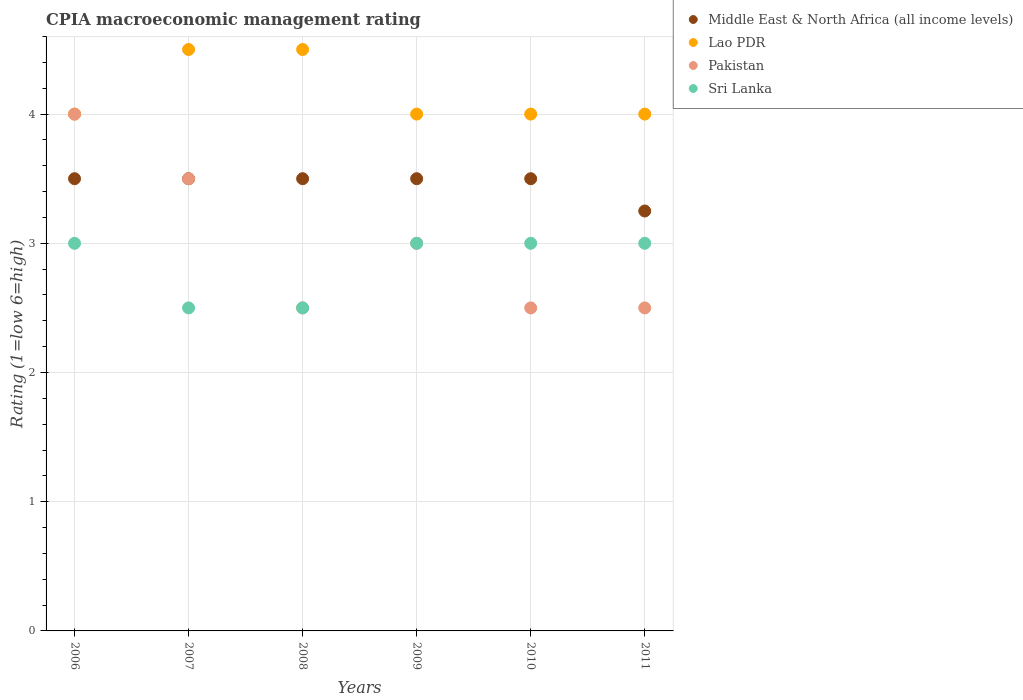Is the number of dotlines equal to the number of legend labels?
Make the answer very short. Yes. In which year was the CPIA rating in Sri Lanka maximum?
Make the answer very short. 2006. In which year was the CPIA rating in Lao PDR minimum?
Provide a succinct answer. 2006. What is the total CPIA rating in Middle East & North Africa (all income levels) in the graph?
Your answer should be compact. 20.75. What is the difference between the CPIA rating in Pakistan in 2006 and the CPIA rating in Sri Lanka in 2011?
Your answer should be compact. 1. What is the ratio of the CPIA rating in Pakistan in 2009 to that in 2011?
Your response must be concise. 1.2. Is the CPIA rating in Sri Lanka in 2008 less than that in 2010?
Your answer should be compact. Yes. Is the difference between the CPIA rating in Middle East & North Africa (all income levels) in 2007 and 2010 greater than the difference between the CPIA rating in Sri Lanka in 2007 and 2010?
Your answer should be compact. Yes. What is the difference between the highest and the second highest CPIA rating in Sri Lanka?
Offer a terse response. 0. What is the difference between the highest and the lowest CPIA rating in Middle East & North Africa (all income levels)?
Give a very brief answer. 0.25. Is the sum of the CPIA rating in Sri Lanka in 2006 and 2008 greater than the maximum CPIA rating in Middle East & North Africa (all income levels) across all years?
Provide a short and direct response. Yes. Is it the case that in every year, the sum of the CPIA rating in Lao PDR and CPIA rating in Pakistan  is greater than the sum of CPIA rating in Middle East & North Africa (all income levels) and CPIA rating in Sri Lanka?
Give a very brief answer. Yes. Is it the case that in every year, the sum of the CPIA rating in Pakistan and CPIA rating in Middle East & North Africa (all income levels)  is greater than the CPIA rating in Sri Lanka?
Your response must be concise. Yes. Does the CPIA rating in Sri Lanka monotonically increase over the years?
Your response must be concise. No. How many dotlines are there?
Your answer should be compact. 4. How many years are there in the graph?
Offer a very short reply. 6. What is the difference between two consecutive major ticks on the Y-axis?
Make the answer very short. 1. Where does the legend appear in the graph?
Ensure brevity in your answer.  Top right. How are the legend labels stacked?
Your answer should be compact. Vertical. What is the title of the graph?
Your response must be concise. CPIA macroeconomic management rating. What is the Rating (1=low 6=high) of Lao PDR in 2006?
Keep it short and to the point. 4. What is the Rating (1=low 6=high) in Pakistan in 2006?
Your answer should be very brief. 4. What is the Rating (1=low 6=high) of Middle East & North Africa (all income levels) in 2007?
Provide a succinct answer. 3.5. What is the Rating (1=low 6=high) of Pakistan in 2007?
Your answer should be compact. 3.5. What is the Rating (1=low 6=high) of Sri Lanka in 2007?
Keep it short and to the point. 2.5. What is the Rating (1=low 6=high) of Pakistan in 2008?
Offer a terse response. 2.5. What is the Rating (1=low 6=high) of Middle East & North Africa (all income levels) in 2009?
Offer a terse response. 3.5. What is the Rating (1=low 6=high) in Sri Lanka in 2009?
Offer a terse response. 3. What is the Rating (1=low 6=high) of Middle East & North Africa (all income levels) in 2010?
Provide a succinct answer. 3.5. What is the Rating (1=low 6=high) in Pakistan in 2010?
Give a very brief answer. 2.5. What is the Rating (1=low 6=high) in Sri Lanka in 2010?
Keep it short and to the point. 3. What is the Rating (1=low 6=high) of Sri Lanka in 2011?
Your answer should be very brief. 3. Across all years, what is the maximum Rating (1=low 6=high) in Middle East & North Africa (all income levels)?
Provide a succinct answer. 3.5. Across all years, what is the maximum Rating (1=low 6=high) of Lao PDR?
Give a very brief answer. 4.5. Across all years, what is the minimum Rating (1=low 6=high) of Pakistan?
Your answer should be compact. 2.5. What is the total Rating (1=low 6=high) in Middle East & North Africa (all income levels) in the graph?
Offer a very short reply. 20.75. What is the total Rating (1=low 6=high) of Lao PDR in the graph?
Your answer should be compact. 25. What is the total Rating (1=low 6=high) in Pakistan in the graph?
Make the answer very short. 18. What is the total Rating (1=low 6=high) of Sri Lanka in the graph?
Keep it short and to the point. 17. What is the difference between the Rating (1=low 6=high) in Middle East & North Africa (all income levels) in 2006 and that in 2007?
Offer a very short reply. 0. What is the difference between the Rating (1=low 6=high) in Sri Lanka in 2006 and that in 2007?
Offer a very short reply. 0.5. What is the difference between the Rating (1=low 6=high) in Lao PDR in 2006 and that in 2008?
Provide a short and direct response. -0.5. What is the difference between the Rating (1=low 6=high) of Pakistan in 2006 and that in 2008?
Give a very brief answer. 1.5. What is the difference between the Rating (1=low 6=high) in Sri Lanka in 2006 and that in 2008?
Keep it short and to the point. 0.5. What is the difference between the Rating (1=low 6=high) in Middle East & North Africa (all income levels) in 2006 and that in 2009?
Offer a terse response. 0. What is the difference between the Rating (1=low 6=high) in Lao PDR in 2006 and that in 2009?
Ensure brevity in your answer.  0. What is the difference between the Rating (1=low 6=high) in Pakistan in 2006 and that in 2009?
Your answer should be compact. 1. What is the difference between the Rating (1=low 6=high) of Sri Lanka in 2006 and that in 2009?
Provide a succinct answer. 0. What is the difference between the Rating (1=low 6=high) in Middle East & North Africa (all income levels) in 2006 and that in 2010?
Offer a terse response. 0. What is the difference between the Rating (1=low 6=high) of Lao PDR in 2006 and that in 2010?
Ensure brevity in your answer.  0. What is the difference between the Rating (1=low 6=high) of Pakistan in 2006 and that in 2010?
Your response must be concise. 1.5. What is the difference between the Rating (1=low 6=high) in Lao PDR in 2006 and that in 2011?
Keep it short and to the point. 0. What is the difference between the Rating (1=low 6=high) of Pakistan in 2006 and that in 2011?
Provide a short and direct response. 1.5. What is the difference between the Rating (1=low 6=high) in Sri Lanka in 2007 and that in 2008?
Keep it short and to the point. 0. What is the difference between the Rating (1=low 6=high) in Middle East & North Africa (all income levels) in 2007 and that in 2009?
Ensure brevity in your answer.  0. What is the difference between the Rating (1=low 6=high) in Sri Lanka in 2007 and that in 2009?
Offer a very short reply. -0.5. What is the difference between the Rating (1=low 6=high) in Middle East & North Africa (all income levels) in 2007 and that in 2010?
Offer a very short reply. 0. What is the difference between the Rating (1=low 6=high) of Lao PDR in 2007 and that in 2010?
Give a very brief answer. 0.5. What is the difference between the Rating (1=low 6=high) in Pakistan in 2007 and that in 2010?
Provide a succinct answer. 1. What is the difference between the Rating (1=low 6=high) in Sri Lanka in 2007 and that in 2010?
Your response must be concise. -0.5. What is the difference between the Rating (1=low 6=high) in Lao PDR in 2007 and that in 2011?
Your answer should be very brief. 0.5. What is the difference between the Rating (1=low 6=high) of Pakistan in 2007 and that in 2011?
Your answer should be compact. 1. What is the difference between the Rating (1=low 6=high) in Middle East & North Africa (all income levels) in 2008 and that in 2009?
Keep it short and to the point. 0. What is the difference between the Rating (1=low 6=high) of Lao PDR in 2008 and that in 2009?
Your answer should be very brief. 0.5. What is the difference between the Rating (1=low 6=high) in Pakistan in 2008 and that in 2009?
Ensure brevity in your answer.  -0.5. What is the difference between the Rating (1=low 6=high) in Sri Lanka in 2008 and that in 2009?
Give a very brief answer. -0.5. What is the difference between the Rating (1=low 6=high) of Pakistan in 2008 and that in 2010?
Offer a terse response. 0. What is the difference between the Rating (1=low 6=high) of Sri Lanka in 2008 and that in 2010?
Provide a succinct answer. -0.5. What is the difference between the Rating (1=low 6=high) in Middle East & North Africa (all income levels) in 2008 and that in 2011?
Make the answer very short. 0.25. What is the difference between the Rating (1=low 6=high) in Pakistan in 2008 and that in 2011?
Offer a very short reply. 0. What is the difference between the Rating (1=low 6=high) of Sri Lanka in 2008 and that in 2011?
Offer a very short reply. -0.5. What is the difference between the Rating (1=low 6=high) in Middle East & North Africa (all income levels) in 2009 and that in 2010?
Your answer should be very brief. 0. What is the difference between the Rating (1=low 6=high) of Lao PDR in 2009 and that in 2010?
Your answer should be very brief. 0. What is the difference between the Rating (1=low 6=high) of Pakistan in 2009 and that in 2010?
Your answer should be compact. 0.5. What is the difference between the Rating (1=low 6=high) in Sri Lanka in 2009 and that in 2010?
Keep it short and to the point. 0. What is the difference between the Rating (1=low 6=high) in Middle East & North Africa (all income levels) in 2009 and that in 2011?
Your response must be concise. 0.25. What is the difference between the Rating (1=low 6=high) in Pakistan in 2009 and that in 2011?
Give a very brief answer. 0.5. What is the difference between the Rating (1=low 6=high) in Sri Lanka in 2009 and that in 2011?
Offer a terse response. 0. What is the difference between the Rating (1=low 6=high) in Lao PDR in 2010 and that in 2011?
Ensure brevity in your answer.  0. What is the difference between the Rating (1=low 6=high) of Middle East & North Africa (all income levels) in 2006 and the Rating (1=low 6=high) of Pakistan in 2007?
Make the answer very short. 0. What is the difference between the Rating (1=low 6=high) in Middle East & North Africa (all income levels) in 2006 and the Rating (1=low 6=high) in Sri Lanka in 2007?
Your answer should be very brief. 1. What is the difference between the Rating (1=low 6=high) of Lao PDR in 2006 and the Rating (1=low 6=high) of Sri Lanka in 2007?
Make the answer very short. 1.5. What is the difference between the Rating (1=low 6=high) of Pakistan in 2006 and the Rating (1=low 6=high) of Sri Lanka in 2007?
Offer a very short reply. 1.5. What is the difference between the Rating (1=low 6=high) of Middle East & North Africa (all income levels) in 2006 and the Rating (1=low 6=high) of Pakistan in 2008?
Your answer should be compact. 1. What is the difference between the Rating (1=low 6=high) in Middle East & North Africa (all income levels) in 2006 and the Rating (1=low 6=high) in Sri Lanka in 2008?
Ensure brevity in your answer.  1. What is the difference between the Rating (1=low 6=high) of Lao PDR in 2006 and the Rating (1=low 6=high) of Pakistan in 2008?
Keep it short and to the point. 1.5. What is the difference between the Rating (1=low 6=high) of Middle East & North Africa (all income levels) in 2006 and the Rating (1=low 6=high) of Sri Lanka in 2009?
Provide a succinct answer. 0.5. What is the difference between the Rating (1=low 6=high) in Lao PDR in 2006 and the Rating (1=low 6=high) in Pakistan in 2009?
Keep it short and to the point. 1. What is the difference between the Rating (1=low 6=high) of Pakistan in 2006 and the Rating (1=low 6=high) of Sri Lanka in 2009?
Your response must be concise. 1. What is the difference between the Rating (1=low 6=high) in Middle East & North Africa (all income levels) in 2006 and the Rating (1=low 6=high) in Sri Lanka in 2010?
Your answer should be compact. 0.5. What is the difference between the Rating (1=low 6=high) of Pakistan in 2006 and the Rating (1=low 6=high) of Sri Lanka in 2010?
Your answer should be compact. 1. What is the difference between the Rating (1=low 6=high) in Middle East & North Africa (all income levels) in 2006 and the Rating (1=low 6=high) in Lao PDR in 2011?
Ensure brevity in your answer.  -0.5. What is the difference between the Rating (1=low 6=high) of Middle East & North Africa (all income levels) in 2006 and the Rating (1=low 6=high) of Sri Lanka in 2011?
Your answer should be compact. 0.5. What is the difference between the Rating (1=low 6=high) of Lao PDR in 2006 and the Rating (1=low 6=high) of Pakistan in 2011?
Offer a very short reply. 1.5. What is the difference between the Rating (1=low 6=high) in Middle East & North Africa (all income levels) in 2007 and the Rating (1=low 6=high) in Pakistan in 2008?
Keep it short and to the point. 1. What is the difference between the Rating (1=low 6=high) of Middle East & North Africa (all income levels) in 2007 and the Rating (1=low 6=high) of Sri Lanka in 2008?
Provide a succinct answer. 1. What is the difference between the Rating (1=low 6=high) in Lao PDR in 2007 and the Rating (1=low 6=high) in Sri Lanka in 2008?
Keep it short and to the point. 2. What is the difference between the Rating (1=low 6=high) in Pakistan in 2007 and the Rating (1=low 6=high) in Sri Lanka in 2008?
Make the answer very short. 1. What is the difference between the Rating (1=low 6=high) of Middle East & North Africa (all income levels) in 2007 and the Rating (1=low 6=high) of Sri Lanka in 2009?
Offer a terse response. 0.5. What is the difference between the Rating (1=low 6=high) of Lao PDR in 2007 and the Rating (1=low 6=high) of Pakistan in 2009?
Ensure brevity in your answer.  1.5. What is the difference between the Rating (1=low 6=high) in Lao PDR in 2007 and the Rating (1=low 6=high) in Sri Lanka in 2009?
Ensure brevity in your answer.  1.5. What is the difference between the Rating (1=low 6=high) in Middle East & North Africa (all income levels) in 2007 and the Rating (1=low 6=high) in Lao PDR in 2010?
Provide a succinct answer. -0.5. What is the difference between the Rating (1=low 6=high) of Lao PDR in 2007 and the Rating (1=low 6=high) of Pakistan in 2010?
Your response must be concise. 2. What is the difference between the Rating (1=low 6=high) of Lao PDR in 2007 and the Rating (1=low 6=high) of Sri Lanka in 2010?
Your response must be concise. 1.5. What is the difference between the Rating (1=low 6=high) in Middle East & North Africa (all income levels) in 2007 and the Rating (1=low 6=high) in Lao PDR in 2011?
Provide a short and direct response. -0.5. What is the difference between the Rating (1=low 6=high) of Lao PDR in 2007 and the Rating (1=low 6=high) of Pakistan in 2011?
Keep it short and to the point. 2. What is the difference between the Rating (1=low 6=high) of Lao PDR in 2007 and the Rating (1=low 6=high) of Sri Lanka in 2011?
Your response must be concise. 1.5. What is the difference between the Rating (1=low 6=high) of Pakistan in 2007 and the Rating (1=low 6=high) of Sri Lanka in 2011?
Your response must be concise. 0.5. What is the difference between the Rating (1=low 6=high) in Middle East & North Africa (all income levels) in 2008 and the Rating (1=low 6=high) in Pakistan in 2009?
Your answer should be very brief. 0.5. What is the difference between the Rating (1=low 6=high) of Lao PDR in 2008 and the Rating (1=low 6=high) of Pakistan in 2009?
Provide a succinct answer. 1.5. What is the difference between the Rating (1=low 6=high) of Middle East & North Africa (all income levels) in 2008 and the Rating (1=low 6=high) of Pakistan in 2010?
Offer a terse response. 1. What is the difference between the Rating (1=low 6=high) of Middle East & North Africa (all income levels) in 2008 and the Rating (1=low 6=high) of Lao PDR in 2011?
Offer a terse response. -0.5. What is the difference between the Rating (1=low 6=high) of Middle East & North Africa (all income levels) in 2008 and the Rating (1=low 6=high) of Sri Lanka in 2011?
Ensure brevity in your answer.  0.5. What is the difference between the Rating (1=low 6=high) in Lao PDR in 2008 and the Rating (1=low 6=high) in Sri Lanka in 2011?
Your answer should be very brief. 1.5. What is the difference between the Rating (1=low 6=high) of Middle East & North Africa (all income levels) in 2009 and the Rating (1=low 6=high) of Lao PDR in 2010?
Make the answer very short. -0.5. What is the difference between the Rating (1=low 6=high) in Lao PDR in 2009 and the Rating (1=low 6=high) in Sri Lanka in 2010?
Make the answer very short. 1. What is the difference between the Rating (1=low 6=high) of Pakistan in 2009 and the Rating (1=low 6=high) of Sri Lanka in 2010?
Your answer should be very brief. 0. What is the difference between the Rating (1=low 6=high) in Middle East & North Africa (all income levels) in 2009 and the Rating (1=low 6=high) in Pakistan in 2011?
Your answer should be very brief. 1. What is the difference between the Rating (1=low 6=high) in Lao PDR in 2009 and the Rating (1=low 6=high) in Sri Lanka in 2011?
Keep it short and to the point. 1. What is the difference between the Rating (1=low 6=high) of Pakistan in 2009 and the Rating (1=low 6=high) of Sri Lanka in 2011?
Provide a short and direct response. 0. What is the difference between the Rating (1=low 6=high) in Middle East & North Africa (all income levels) in 2010 and the Rating (1=low 6=high) in Pakistan in 2011?
Make the answer very short. 1. What is the difference between the Rating (1=low 6=high) of Lao PDR in 2010 and the Rating (1=low 6=high) of Sri Lanka in 2011?
Offer a very short reply. 1. What is the average Rating (1=low 6=high) of Middle East & North Africa (all income levels) per year?
Ensure brevity in your answer.  3.46. What is the average Rating (1=low 6=high) in Lao PDR per year?
Offer a very short reply. 4.17. What is the average Rating (1=low 6=high) of Pakistan per year?
Your response must be concise. 3. What is the average Rating (1=low 6=high) in Sri Lanka per year?
Provide a short and direct response. 2.83. In the year 2006, what is the difference between the Rating (1=low 6=high) in Middle East & North Africa (all income levels) and Rating (1=low 6=high) in Sri Lanka?
Make the answer very short. 0.5. In the year 2006, what is the difference between the Rating (1=low 6=high) in Lao PDR and Rating (1=low 6=high) in Pakistan?
Keep it short and to the point. 0. In the year 2006, what is the difference between the Rating (1=low 6=high) in Lao PDR and Rating (1=low 6=high) in Sri Lanka?
Give a very brief answer. 1. In the year 2006, what is the difference between the Rating (1=low 6=high) of Pakistan and Rating (1=low 6=high) of Sri Lanka?
Your answer should be compact. 1. In the year 2007, what is the difference between the Rating (1=low 6=high) of Middle East & North Africa (all income levels) and Rating (1=low 6=high) of Sri Lanka?
Provide a short and direct response. 1. In the year 2007, what is the difference between the Rating (1=low 6=high) of Lao PDR and Rating (1=low 6=high) of Pakistan?
Make the answer very short. 1. In the year 2007, what is the difference between the Rating (1=low 6=high) of Lao PDR and Rating (1=low 6=high) of Sri Lanka?
Offer a very short reply. 2. In the year 2007, what is the difference between the Rating (1=low 6=high) of Pakistan and Rating (1=low 6=high) of Sri Lanka?
Provide a short and direct response. 1. In the year 2008, what is the difference between the Rating (1=low 6=high) in Lao PDR and Rating (1=low 6=high) in Pakistan?
Your response must be concise. 2. In the year 2008, what is the difference between the Rating (1=low 6=high) in Lao PDR and Rating (1=low 6=high) in Sri Lanka?
Your answer should be compact. 2. In the year 2010, what is the difference between the Rating (1=low 6=high) of Middle East & North Africa (all income levels) and Rating (1=low 6=high) of Pakistan?
Your response must be concise. 1. In the year 2010, what is the difference between the Rating (1=low 6=high) of Lao PDR and Rating (1=low 6=high) of Pakistan?
Offer a very short reply. 1.5. In the year 2010, what is the difference between the Rating (1=low 6=high) of Lao PDR and Rating (1=low 6=high) of Sri Lanka?
Provide a short and direct response. 1. In the year 2011, what is the difference between the Rating (1=low 6=high) of Middle East & North Africa (all income levels) and Rating (1=low 6=high) of Lao PDR?
Your answer should be very brief. -0.75. In the year 2011, what is the difference between the Rating (1=low 6=high) of Lao PDR and Rating (1=low 6=high) of Pakistan?
Offer a very short reply. 1.5. In the year 2011, what is the difference between the Rating (1=low 6=high) of Lao PDR and Rating (1=low 6=high) of Sri Lanka?
Give a very brief answer. 1. In the year 2011, what is the difference between the Rating (1=low 6=high) in Pakistan and Rating (1=low 6=high) in Sri Lanka?
Give a very brief answer. -0.5. What is the ratio of the Rating (1=low 6=high) of Middle East & North Africa (all income levels) in 2006 to that in 2007?
Your response must be concise. 1. What is the ratio of the Rating (1=low 6=high) in Pakistan in 2006 to that in 2007?
Your answer should be very brief. 1.14. What is the ratio of the Rating (1=low 6=high) in Sri Lanka in 2006 to that in 2007?
Offer a very short reply. 1.2. What is the ratio of the Rating (1=low 6=high) in Middle East & North Africa (all income levels) in 2006 to that in 2008?
Your response must be concise. 1. What is the ratio of the Rating (1=low 6=high) of Lao PDR in 2006 to that in 2008?
Your answer should be compact. 0.89. What is the ratio of the Rating (1=low 6=high) of Sri Lanka in 2006 to that in 2008?
Provide a succinct answer. 1.2. What is the ratio of the Rating (1=low 6=high) in Middle East & North Africa (all income levels) in 2006 to that in 2009?
Ensure brevity in your answer.  1. What is the ratio of the Rating (1=low 6=high) of Pakistan in 2006 to that in 2009?
Provide a short and direct response. 1.33. What is the ratio of the Rating (1=low 6=high) of Middle East & North Africa (all income levels) in 2006 to that in 2010?
Your answer should be very brief. 1. What is the ratio of the Rating (1=low 6=high) in Pakistan in 2006 to that in 2010?
Keep it short and to the point. 1.6. What is the ratio of the Rating (1=low 6=high) in Sri Lanka in 2006 to that in 2010?
Ensure brevity in your answer.  1. What is the ratio of the Rating (1=low 6=high) in Middle East & North Africa (all income levels) in 2006 to that in 2011?
Make the answer very short. 1.08. What is the ratio of the Rating (1=low 6=high) of Lao PDR in 2006 to that in 2011?
Keep it short and to the point. 1. What is the ratio of the Rating (1=low 6=high) of Pakistan in 2006 to that in 2011?
Ensure brevity in your answer.  1.6. What is the ratio of the Rating (1=low 6=high) in Lao PDR in 2007 to that in 2008?
Your answer should be compact. 1. What is the ratio of the Rating (1=low 6=high) in Sri Lanka in 2007 to that in 2008?
Your response must be concise. 1. What is the ratio of the Rating (1=low 6=high) in Pakistan in 2007 to that in 2009?
Give a very brief answer. 1.17. What is the ratio of the Rating (1=low 6=high) of Sri Lanka in 2007 to that in 2009?
Ensure brevity in your answer.  0.83. What is the ratio of the Rating (1=low 6=high) of Middle East & North Africa (all income levels) in 2007 to that in 2010?
Provide a short and direct response. 1. What is the ratio of the Rating (1=low 6=high) in Sri Lanka in 2007 to that in 2010?
Offer a very short reply. 0.83. What is the ratio of the Rating (1=low 6=high) of Middle East & North Africa (all income levels) in 2007 to that in 2011?
Ensure brevity in your answer.  1.08. What is the ratio of the Rating (1=low 6=high) of Lao PDR in 2007 to that in 2011?
Your answer should be very brief. 1.12. What is the ratio of the Rating (1=low 6=high) in Sri Lanka in 2007 to that in 2011?
Provide a short and direct response. 0.83. What is the ratio of the Rating (1=low 6=high) in Middle East & North Africa (all income levels) in 2008 to that in 2009?
Your answer should be compact. 1. What is the ratio of the Rating (1=low 6=high) of Lao PDR in 2008 to that in 2009?
Offer a terse response. 1.12. What is the ratio of the Rating (1=low 6=high) of Pakistan in 2008 to that in 2009?
Ensure brevity in your answer.  0.83. What is the ratio of the Rating (1=low 6=high) of Sri Lanka in 2008 to that in 2009?
Keep it short and to the point. 0.83. What is the ratio of the Rating (1=low 6=high) in Lao PDR in 2008 to that in 2010?
Offer a very short reply. 1.12. What is the ratio of the Rating (1=low 6=high) in Pakistan in 2008 to that in 2010?
Offer a very short reply. 1. What is the ratio of the Rating (1=low 6=high) in Sri Lanka in 2008 to that in 2010?
Offer a terse response. 0.83. What is the ratio of the Rating (1=low 6=high) in Sri Lanka in 2008 to that in 2011?
Your answer should be very brief. 0.83. What is the ratio of the Rating (1=low 6=high) in Lao PDR in 2009 to that in 2010?
Provide a short and direct response. 1. What is the ratio of the Rating (1=low 6=high) in Pakistan in 2009 to that in 2010?
Your answer should be compact. 1.2. What is the ratio of the Rating (1=low 6=high) in Lao PDR in 2009 to that in 2011?
Offer a terse response. 1. What is the ratio of the Rating (1=low 6=high) of Sri Lanka in 2009 to that in 2011?
Provide a short and direct response. 1. What is the ratio of the Rating (1=low 6=high) in Middle East & North Africa (all income levels) in 2010 to that in 2011?
Offer a very short reply. 1.08. What is the ratio of the Rating (1=low 6=high) of Lao PDR in 2010 to that in 2011?
Keep it short and to the point. 1. What is the ratio of the Rating (1=low 6=high) of Sri Lanka in 2010 to that in 2011?
Your answer should be compact. 1. What is the difference between the highest and the second highest Rating (1=low 6=high) in Middle East & North Africa (all income levels)?
Provide a succinct answer. 0. What is the difference between the highest and the second highest Rating (1=low 6=high) in Pakistan?
Give a very brief answer. 0.5. What is the difference between the highest and the lowest Rating (1=low 6=high) of Lao PDR?
Make the answer very short. 0.5. 